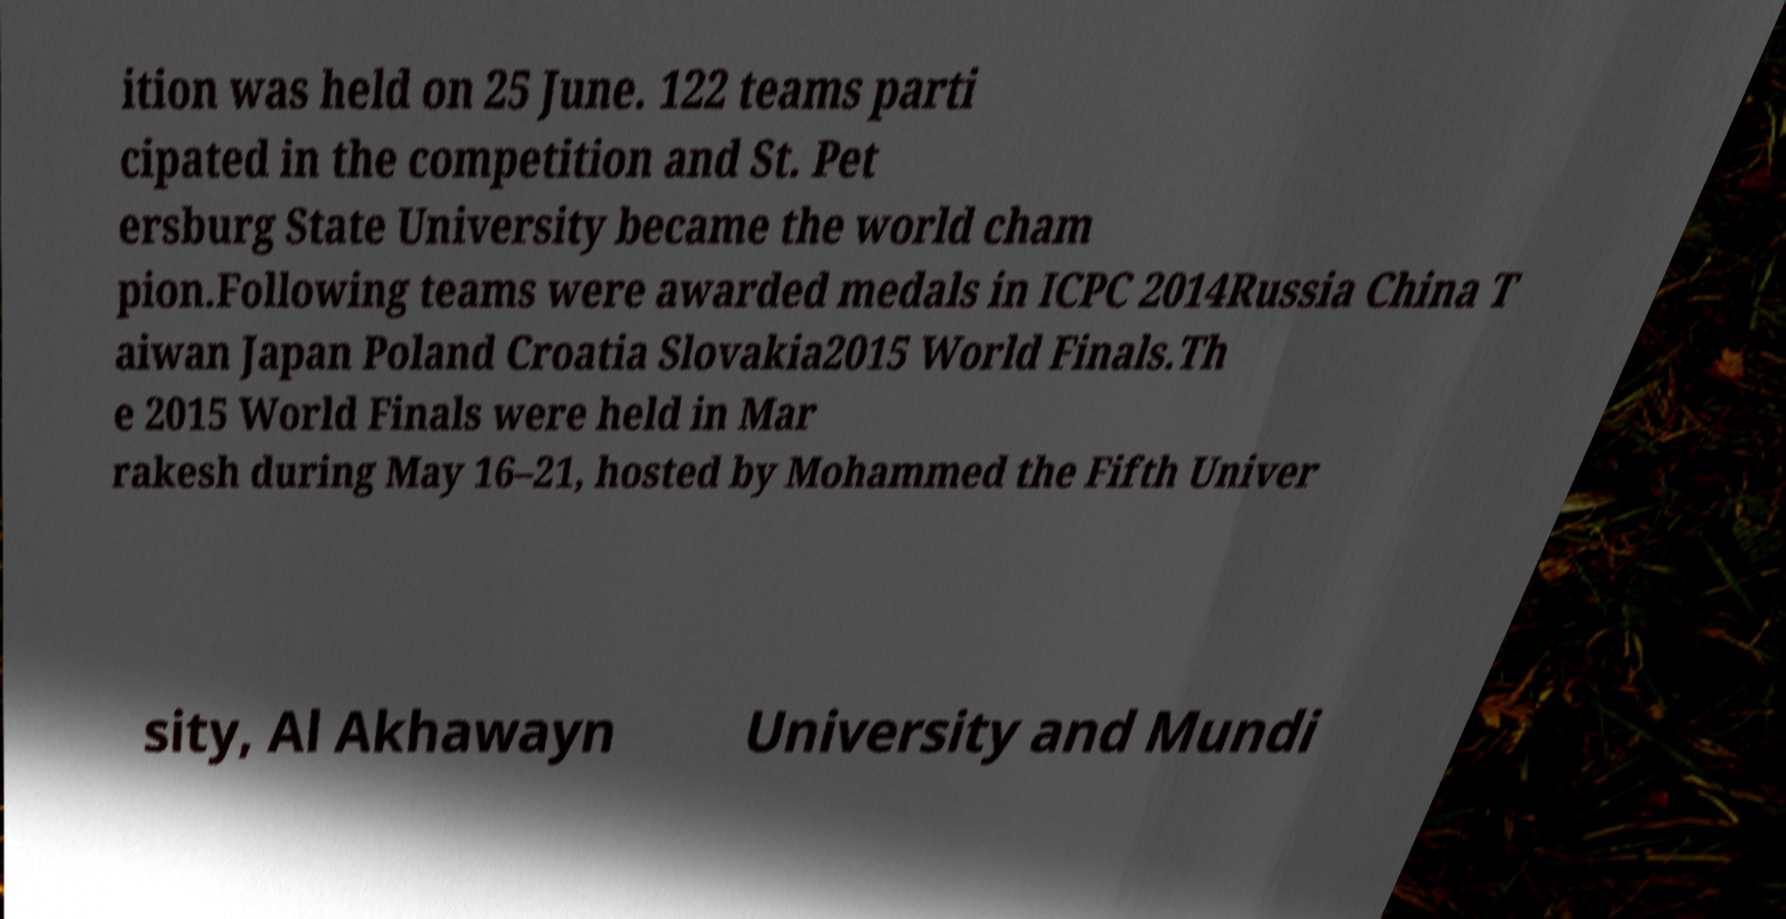Could you assist in decoding the text presented in this image and type it out clearly? ition was held on 25 June. 122 teams parti cipated in the competition and St. Pet ersburg State University became the world cham pion.Following teams were awarded medals in ICPC 2014Russia China T aiwan Japan Poland Croatia Slovakia2015 World Finals.Th e 2015 World Finals were held in Mar rakesh during May 16–21, hosted by Mohammed the Fifth Univer sity, Al Akhawayn University and Mundi 